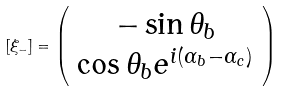<formula> <loc_0><loc_0><loc_500><loc_500>[ \xi _ { - } ] = \left ( \begin{array} { c } - \sin \theta _ { b } \\ \cos \theta _ { b } e ^ { i ( \alpha _ { b } - \alpha _ { c } ) } \end{array} \right )</formula> 